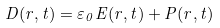<formula> <loc_0><loc_0><loc_500><loc_500>D ( r , t ) = \varepsilon _ { 0 } E ( r , t ) + P ( r , t )</formula> 